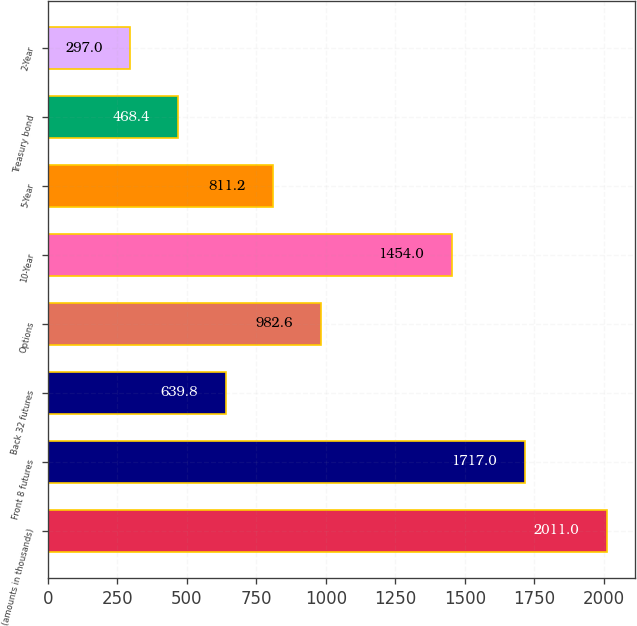Convert chart. <chart><loc_0><loc_0><loc_500><loc_500><bar_chart><fcel>(amounts in thousands)<fcel>Front 8 futures<fcel>Back 32 futures<fcel>Options<fcel>10-Year<fcel>5-Year<fcel>Treasury bond<fcel>2-Year<nl><fcel>2011<fcel>1717<fcel>639.8<fcel>982.6<fcel>1454<fcel>811.2<fcel>468.4<fcel>297<nl></chart> 